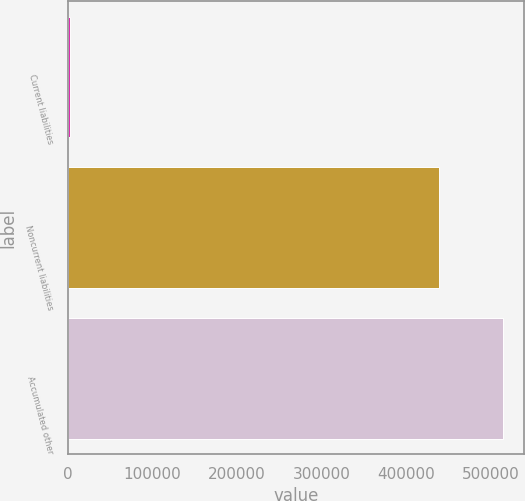<chart> <loc_0><loc_0><loc_500><loc_500><bar_chart><fcel>Current liabilities<fcel>Noncurrent liabilities<fcel>Accumulated other<nl><fcel>2216<fcel>439193<fcel>513924<nl></chart> 